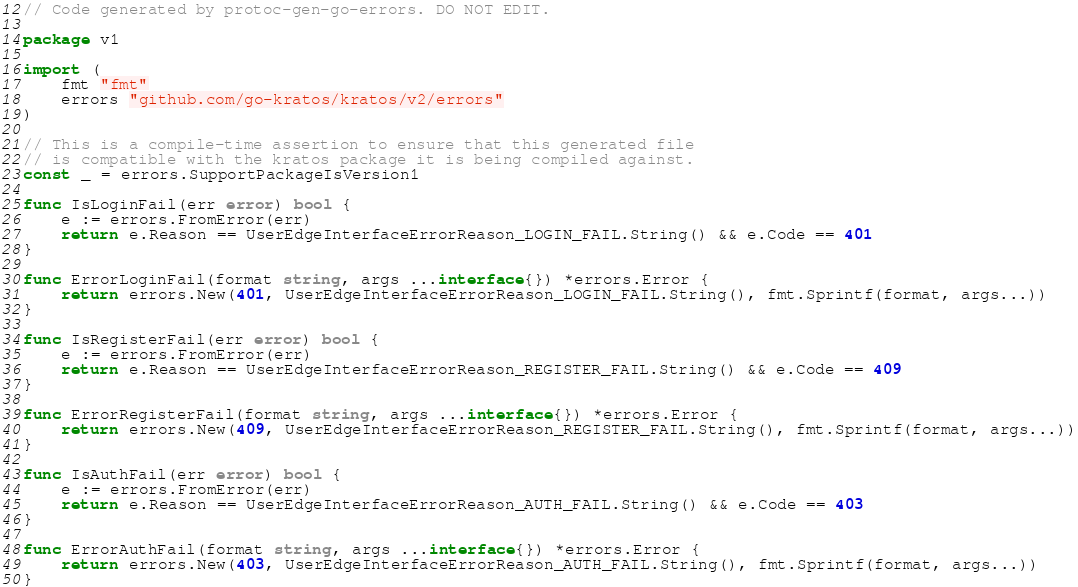Convert code to text. <code><loc_0><loc_0><loc_500><loc_500><_Go_>// Code generated by protoc-gen-go-errors. DO NOT EDIT.

package v1

import (
	fmt "fmt"
	errors "github.com/go-kratos/kratos/v2/errors"
)

// This is a compile-time assertion to ensure that this generated file
// is compatible with the kratos package it is being compiled against.
const _ = errors.SupportPackageIsVersion1

func IsLoginFail(err error) bool {
	e := errors.FromError(err)
	return e.Reason == UserEdgeInterfaceErrorReason_LOGIN_FAIL.String() && e.Code == 401
}

func ErrorLoginFail(format string, args ...interface{}) *errors.Error {
	return errors.New(401, UserEdgeInterfaceErrorReason_LOGIN_FAIL.String(), fmt.Sprintf(format, args...))
}

func IsRegisterFail(err error) bool {
	e := errors.FromError(err)
	return e.Reason == UserEdgeInterfaceErrorReason_REGISTER_FAIL.String() && e.Code == 409
}

func ErrorRegisterFail(format string, args ...interface{}) *errors.Error {
	return errors.New(409, UserEdgeInterfaceErrorReason_REGISTER_FAIL.String(), fmt.Sprintf(format, args...))
}

func IsAuthFail(err error) bool {
	e := errors.FromError(err)
	return e.Reason == UserEdgeInterfaceErrorReason_AUTH_FAIL.String() && e.Code == 403
}

func ErrorAuthFail(format string, args ...interface{}) *errors.Error {
	return errors.New(403, UserEdgeInterfaceErrorReason_AUTH_FAIL.String(), fmt.Sprintf(format, args...))
}
</code> 